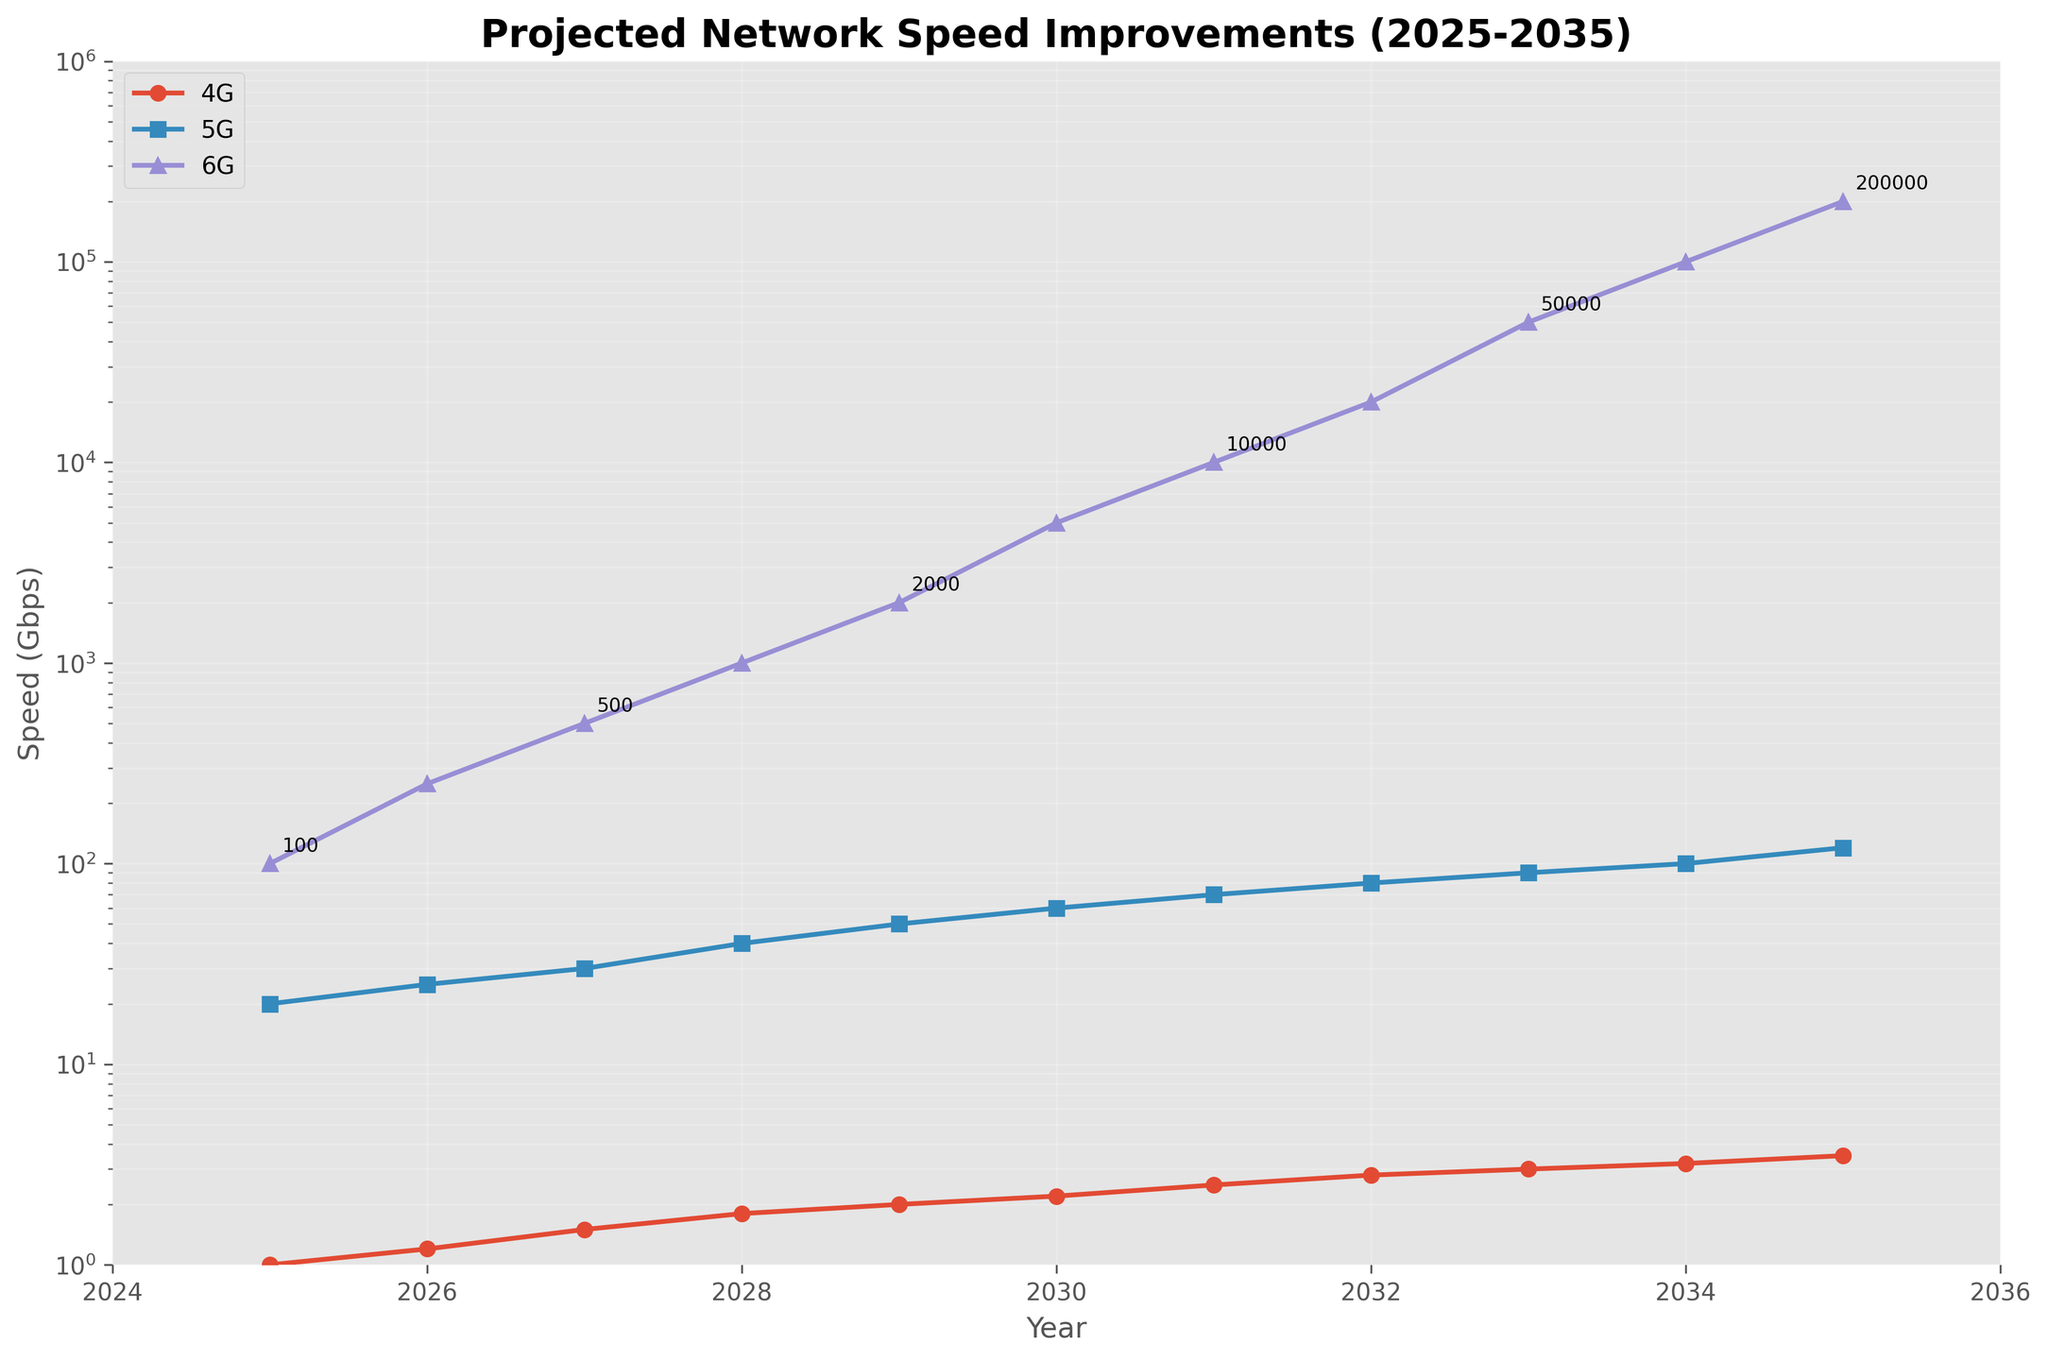What's the projected speed of 6G in the year 2030? Locate the year 2030 on the x-axis, then trace vertically until you reach the 6G line. The label near the point gives the speed. It reads 5000 Gbps.
Answer: 5000 Gbps By how much will 6G speeds outperform 5G speeds in 2033? Find the year 2033 on the x-axis. Compare the vertical position of the 5G and 6G lines. The 5G speed is 90 Gbps and the 6G speed is 50000 Gbps. The difference is 50000 - 90 = 49910 Gbps.
Answer: 49910 Gbps Which technology shows the most significant growth in speed from 2025 to 2035? Compare the slopes of the lines between 2025 and 2035 for 4G, 5G, and 6G. The 6G line shows the steepest increase, indicating the most significant growth.
Answer: 6G What's the average annual growth in 4G speeds from 2025 to 2030? Subtract the 4G speed in 2025 (1 Gbps) from the speed in 2030 (2.2 Gbps). Divide the result by the number of years, (2.2 - 1) / 5 = 0.24 Gbps per year.
Answer: 0.24 Gbps per year By what factor does the 6G speed increase between 2027 and 2032? The 6G speed in 2027 is 500 Gbps, and in 2032, it's 20000 Gbps. The factor increase is 20000 / 500 = 40.
Answer: 40 What year does 6G reach 1000 Gbps? Locate the point where the 6G line first crosses 1000 Gbps. Trace back to the x-axis to find the year. It's in 2028.
Answer: 2028 In what year does 5G surpass 50 Gbps? Locate the 5G line and find the point where it first crosses 50 Gbps. Trace vertically down to the x-axis to determine the year. It happens in 2029.
Answer: 2029 Which year shows the slowest projected increase in 6G speed? Examine the 6G line for the smallest slope between two consecutive years, indicating the slowest increase. The year pairs 2028-2029 and 2029-2030 both show significant jumps, more than other years, hence the slowest is the previous years. The slowest growth appears between 2025 to 2026.
Answer: 2025-2026 What is the median projected speed of 5G from 2025 to 2035? List out all the projected speeds of 5G over these years: 20, 25, 30, 40, 50, 60, 70, 80, 90, 100, 120. The median is the middle value, so it is 60 Gbps.
Answer: 60 Gbps 